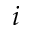<formula> <loc_0><loc_0><loc_500><loc_500>i</formula> 